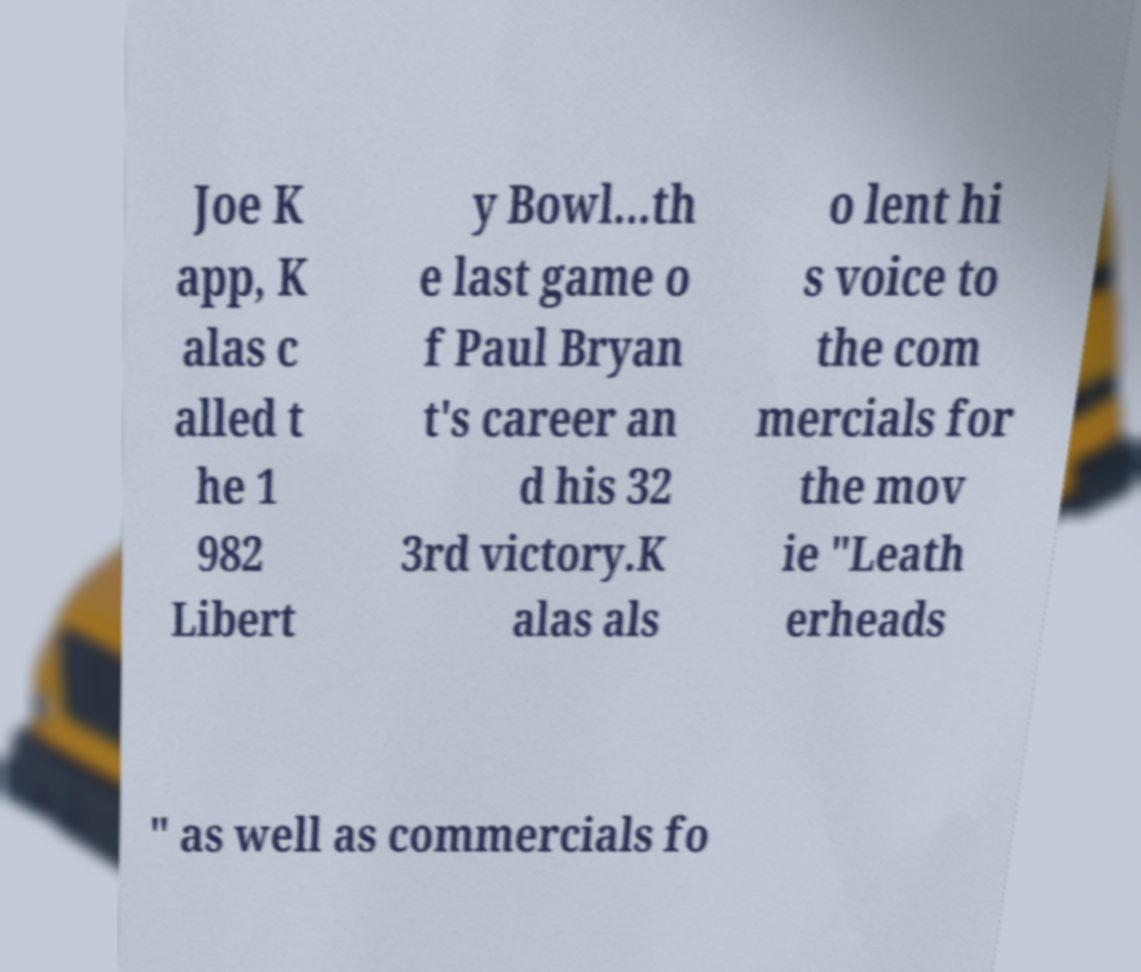For documentation purposes, I need the text within this image transcribed. Could you provide that? Joe K app, K alas c alled t he 1 982 Libert y Bowl...th e last game o f Paul Bryan t's career an d his 32 3rd victory.K alas als o lent hi s voice to the com mercials for the mov ie "Leath erheads " as well as commercials fo 